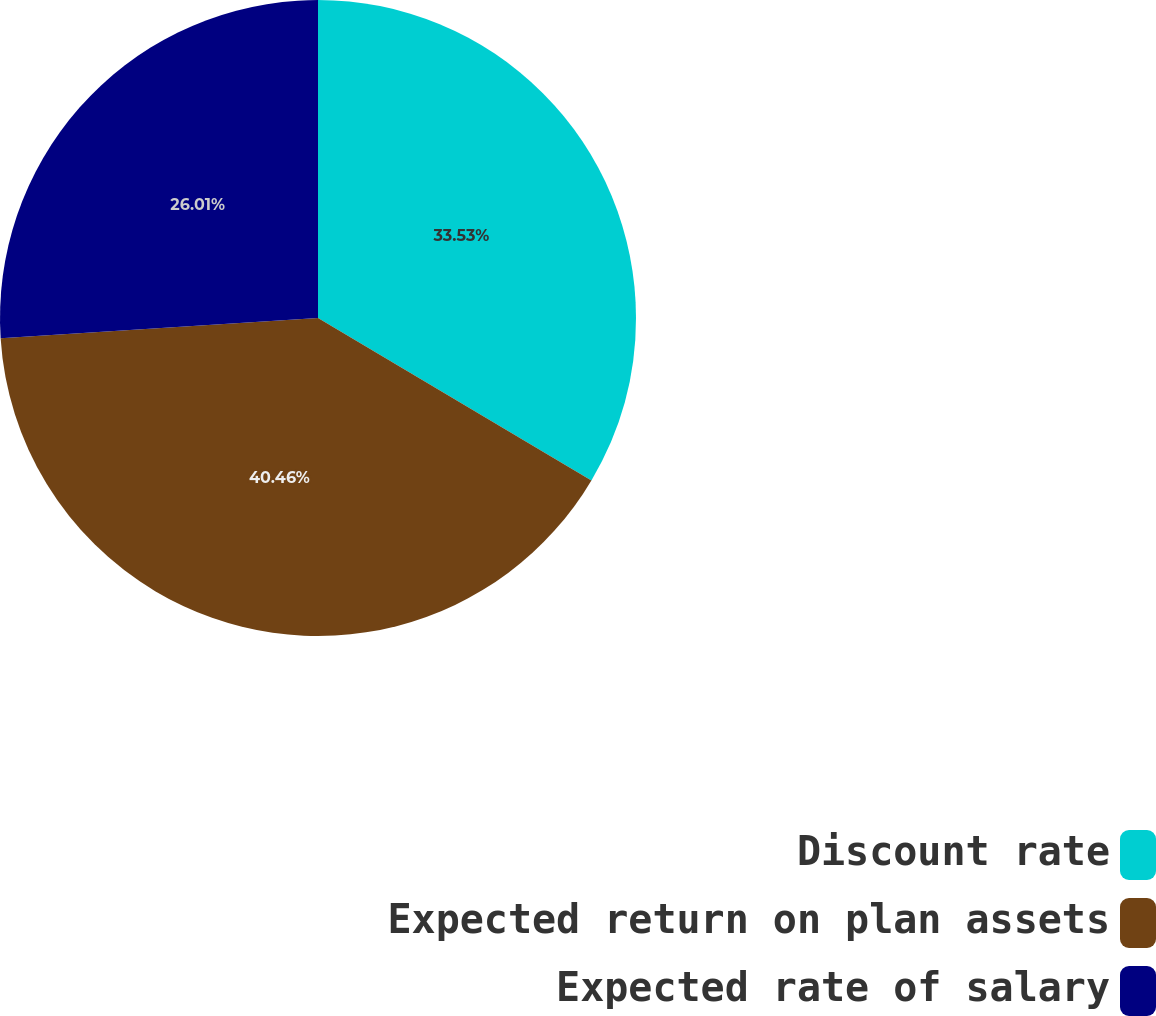<chart> <loc_0><loc_0><loc_500><loc_500><pie_chart><fcel>Discount rate<fcel>Expected return on plan assets<fcel>Expected rate of salary<nl><fcel>33.53%<fcel>40.46%<fcel>26.01%<nl></chart> 